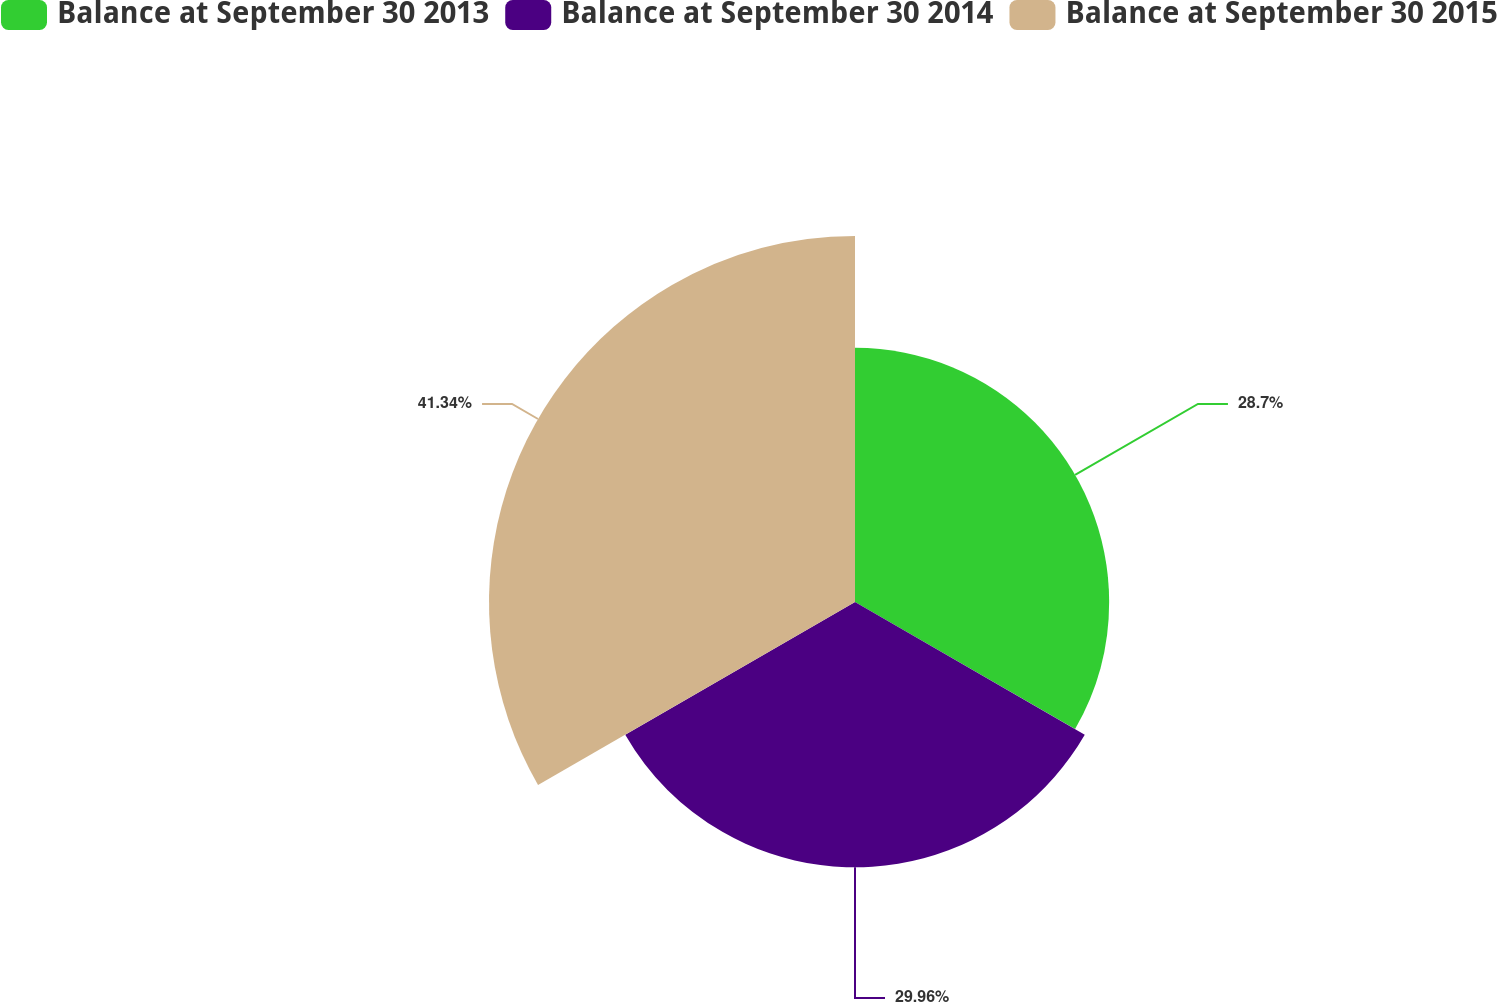Convert chart. <chart><loc_0><loc_0><loc_500><loc_500><pie_chart><fcel>Balance at September 30 2013<fcel>Balance at September 30 2014<fcel>Balance at September 30 2015<nl><fcel>28.7%<fcel>29.96%<fcel>41.33%<nl></chart> 